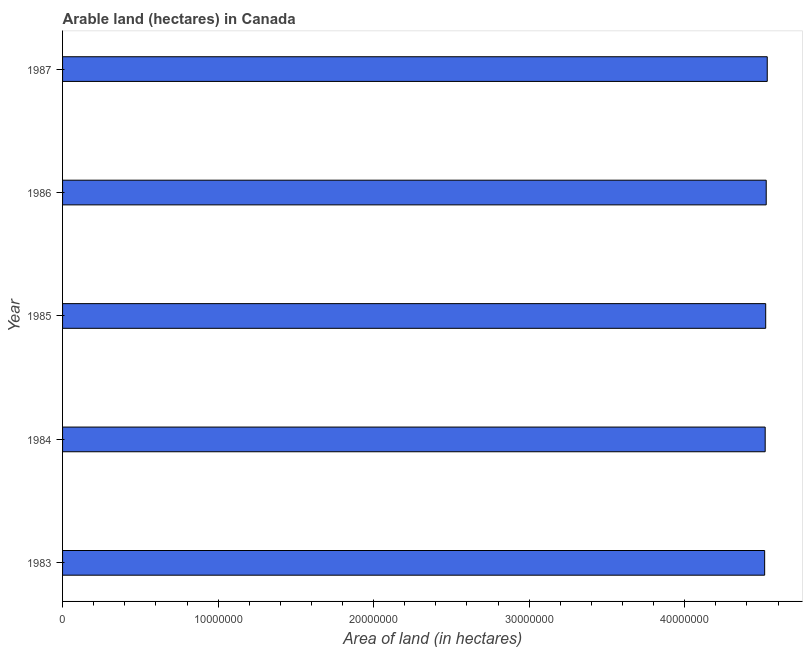What is the title of the graph?
Your answer should be compact. Arable land (hectares) in Canada. What is the label or title of the X-axis?
Your answer should be compact. Area of land (in hectares). What is the area of land in 1986?
Provide a succinct answer. 4.52e+07. Across all years, what is the maximum area of land?
Ensure brevity in your answer.  4.53e+07. Across all years, what is the minimum area of land?
Provide a succinct answer. 4.51e+07. In which year was the area of land minimum?
Ensure brevity in your answer.  1983. What is the sum of the area of land?
Your response must be concise. 2.26e+08. What is the difference between the area of land in 1985 and 1986?
Give a very brief answer. -3.30e+04. What is the average area of land per year?
Your answer should be compact. 4.52e+07. What is the median area of land?
Provide a succinct answer. 4.52e+07. Do a majority of the years between 1986 and 1984 (inclusive) have area of land greater than 42000000 hectares?
Provide a short and direct response. Yes. What is the ratio of the area of land in 1984 to that in 1987?
Provide a succinct answer. 1. What is the difference between the highest and the second highest area of land?
Your response must be concise. 6.70e+04. What is the difference between the highest and the lowest area of land?
Offer a terse response. 1.67e+05. Are all the bars in the graph horizontal?
Ensure brevity in your answer.  Yes. Are the values on the major ticks of X-axis written in scientific E-notation?
Offer a terse response. No. What is the Area of land (in hectares) in 1983?
Provide a succinct answer. 4.51e+07. What is the Area of land (in hectares) of 1984?
Your answer should be compact. 4.52e+07. What is the Area of land (in hectares) of 1985?
Provide a short and direct response. 4.52e+07. What is the Area of land (in hectares) in 1986?
Offer a very short reply. 4.52e+07. What is the Area of land (in hectares) in 1987?
Your response must be concise. 4.53e+07. What is the difference between the Area of land (in hectares) in 1983 and 1984?
Offer a very short reply. -3.40e+04. What is the difference between the Area of land (in hectares) in 1983 and 1985?
Make the answer very short. -6.70e+04. What is the difference between the Area of land (in hectares) in 1983 and 1986?
Keep it short and to the point. -1.00e+05. What is the difference between the Area of land (in hectares) in 1983 and 1987?
Give a very brief answer. -1.67e+05. What is the difference between the Area of land (in hectares) in 1984 and 1985?
Ensure brevity in your answer.  -3.30e+04. What is the difference between the Area of land (in hectares) in 1984 and 1986?
Offer a very short reply. -6.60e+04. What is the difference between the Area of land (in hectares) in 1984 and 1987?
Offer a terse response. -1.33e+05. What is the difference between the Area of land (in hectares) in 1985 and 1986?
Provide a succinct answer. -3.30e+04. What is the difference between the Area of land (in hectares) in 1986 and 1987?
Make the answer very short. -6.70e+04. What is the ratio of the Area of land (in hectares) in 1983 to that in 1984?
Offer a very short reply. 1. What is the ratio of the Area of land (in hectares) in 1983 to that in 1985?
Offer a terse response. 1. What is the ratio of the Area of land (in hectares) in 1983 to that in 1987?
Your answer should be compact. 1. What is the ratio of the Area of land (in hectares) in 1984 to that in 1985?
Provide a succinct answer. 1. What is the ratio of the Area of land (in hectares) in 1984 to that in 1986?
Keep it short and to the point. 1. 